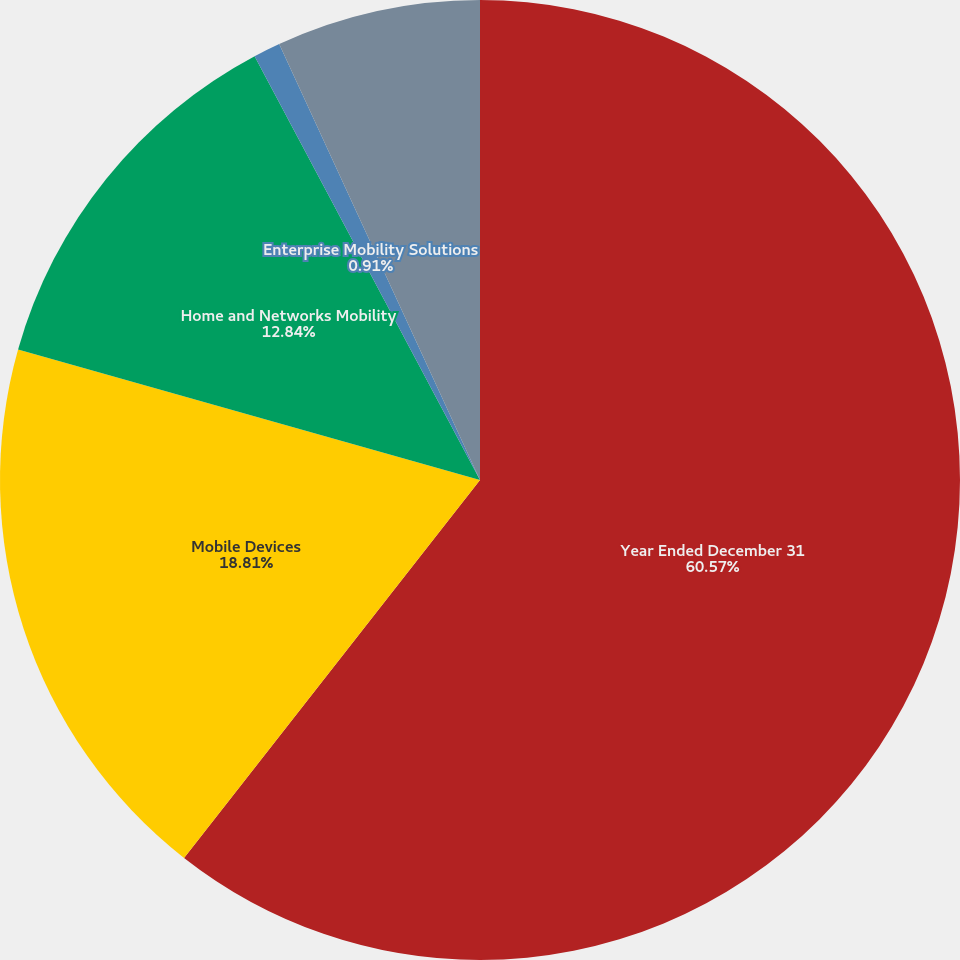<chart> <loc_0><loc_0><loc_500><loc_500><pie_chart><fcel>Year Ended December 31<fcel>Mobile Devices<fcel>Home and Networks Mobility<fcel>Enterprise Mobility Solutions<fcel>Corporate<nl><fcel>60.58%<fcel>18.81%<fcel>12.84%<fcel>0.91%<fcel>6.87%<nl></chart> 